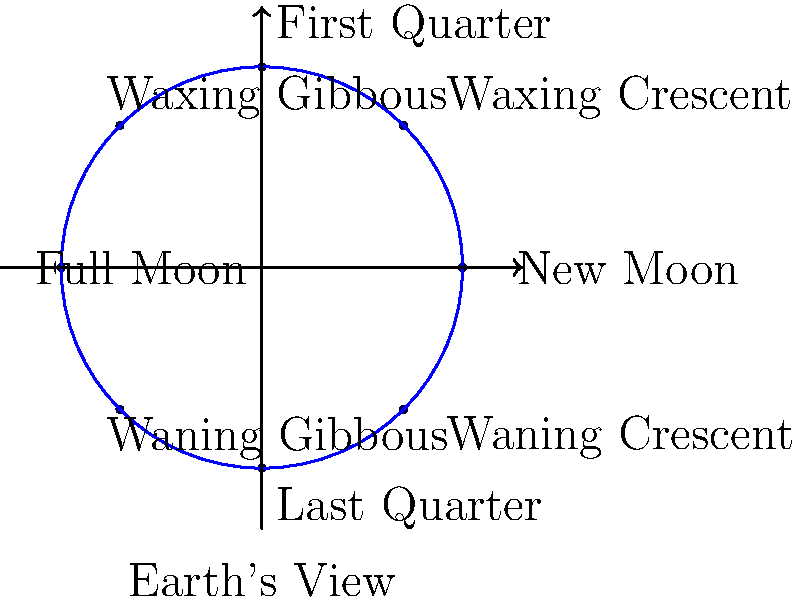In the circular graph representation of lunar phases, what is the angle between each consecutive phase, and how many days approximately pass between these phases in a typical lunar cycle? To answer this question, let's break it down step-by-step:

1. The lunar cycle is represented as a full circle (360°).

2. There are 8 distinct phases shown in the graph: New Moon, Waxing Crescent, First Quarter, Waxing Gibbous, Full Moon, Waning Gibbous, Last Quarter, and Waning Crescent.

3. To find the angle between each consecutive phase:
   $$\text{Angle} = \frac{\text{Total degrees in a circle}}{\text{Number of phases}} = \frac{360°}{8} = 45°$$

4. A typical lunar cycle, also known as a synodic month, lasts approximately 29.5 days.

5. To find the number of days between each phase:
   $$\text{Days between phases} = \frac{\text{Total days in lunar cycle}}{\text{Number of phases}} = \frac{29.5}{8} \approx 3.69 \text{ days}$$

Therefore, each phase is separated by an angle of 45° and approximately 3.69 days in a typical lunar cycle.
Answer: 45°; ~3.69 days 